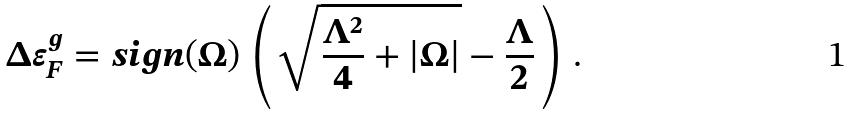<formula> <loc_0><loc_0><loc_500><loc_500>\Delta \varepsilon _ { F } ^ { g } = s i g n ( \Omega ) \, \left ( \, \sqrt { \frac { \Lambda ^ { 2 } } { 4 } + | \Omega | } - \frac { \Lambda } { 2 } \, \right ) \, .</formula> 